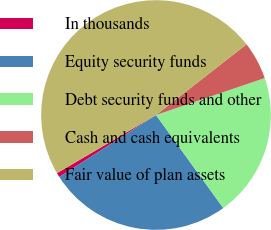Convert chart to OTSL. <chart><loc_0><loc_0><loc_500><loc_500><pie_chart><fcel>In thousands<fcel>Equity security funds<fcel>Debt security funds and other<fcel>Cash and cash equivalents<fcel>Fair value of plan assets<nl><fcel>0.62%<fcel>25.89%<fcel>20.25%<fcel>5.34%<fcel>47.9%<nl></chart> 